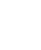<code> <loc_0><loc_0><loc_500><loc_500><_Dockerfile_>


</code> 